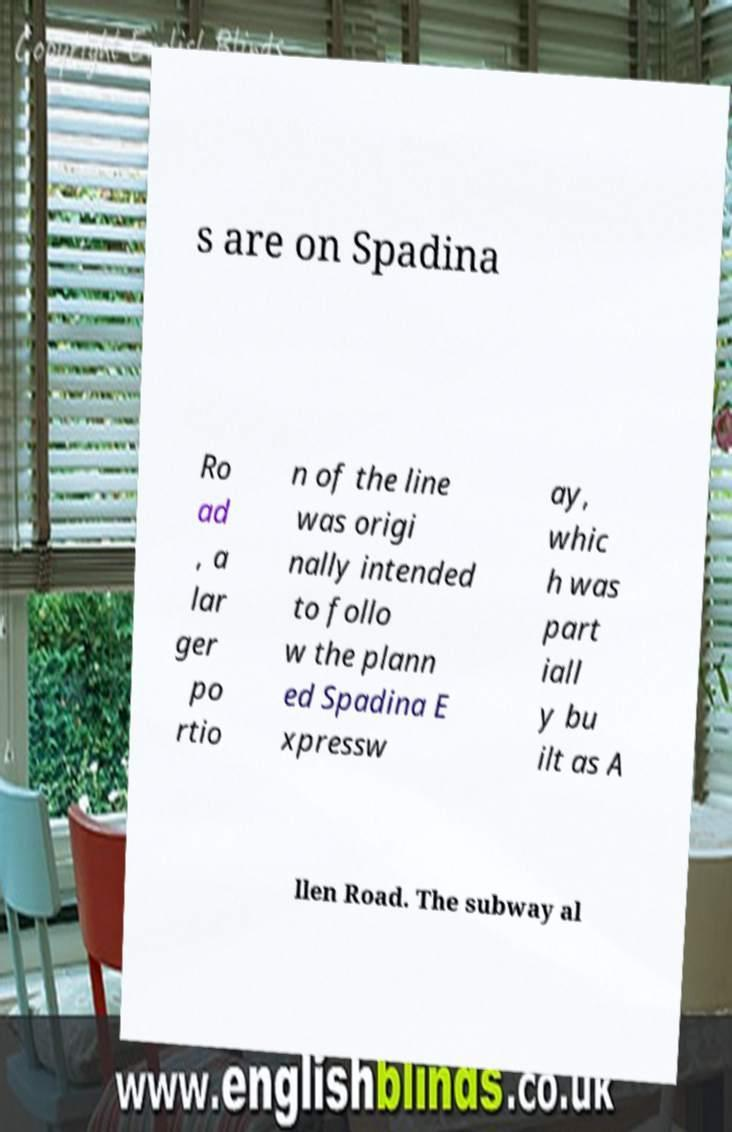Could you assist in decoding the text presented in this image and type it out clearly? s are on Spadina Ro ad , a lar ger po rtio n of the line was origi nally intended to follo w the plann ed Spadina E xpressw ay, whic h was part iall y bu ilt as A llen Road. The subway al 